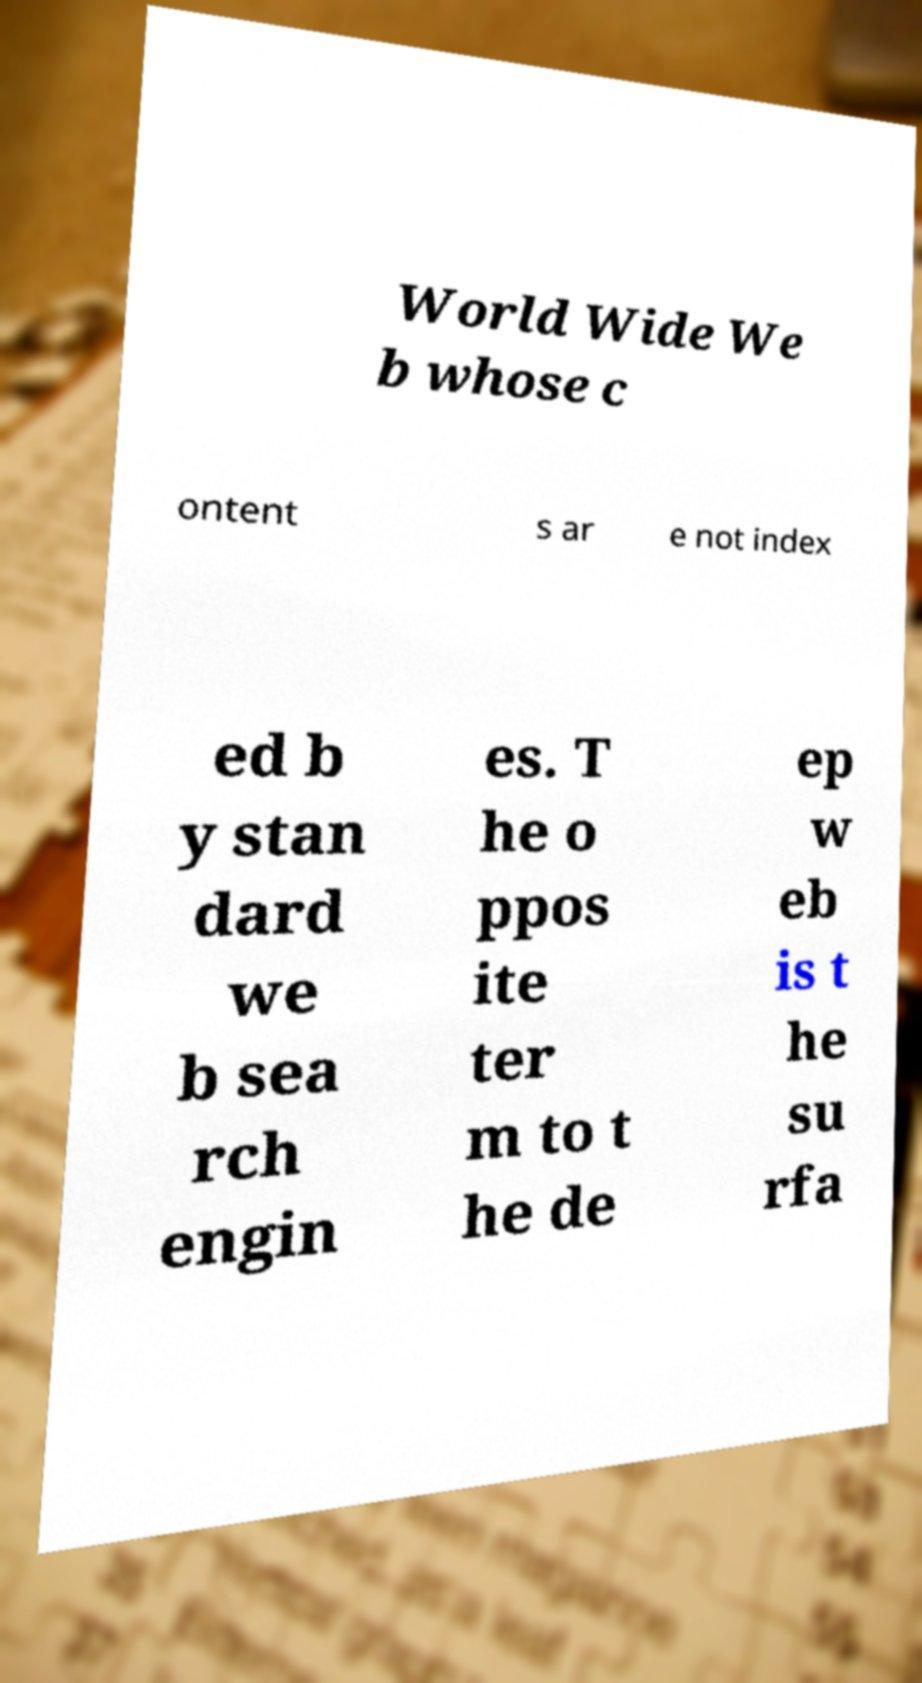I need the written content from this picture converted into text. Can you do that? World Wide We b whose c ontent s ar e not index ed b y stan dard we b sea rch engin es. T he o ppos ite ter m to t he de ep w eb is t he su rfa 